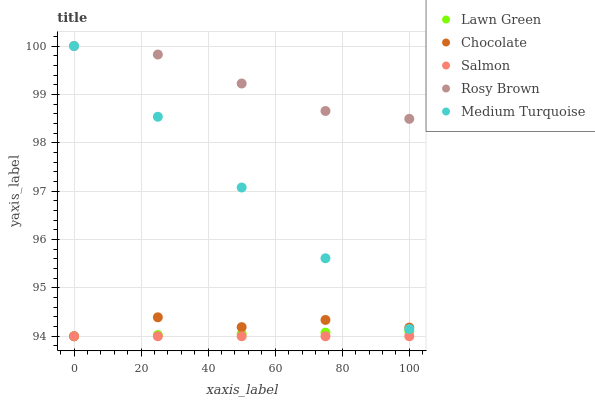Does Salmon have the minimum area under the curve?
Answer yes or no. Yes. Does Rosy Brown have the maximum area under the curve?
Answer yes or no. Yes. Does Rosy Brown have the minimum area under the curve?
Answer yes or no. No. Does Salmon have the maximum area under the curve?
Answer yes or no. No. Is Lawn Green the smoothest?
Answer yes or no. Yes. Is Chocolate the roughest?
Answer yes or no. Yes. Is Rosy Brown the smoothest?
Answer yes or no. No. Is Rosy Brown the roughest?
Answer yes or no. No. Does Lawn Green have the lowest value?
Answer yes or no. Yes. Does Rosy Brown have the lowest value?
Answer yes or no. No. Does Medium Turquoise have the highest value?
Answer yes or no. Yes. Does Salmon have the highest value?
Answer yes or no. No. Is Salmon less than Medium Turquoise?
Answer yes or no. Yes. Is Medium Turquoise greater than Salmon?
Answer yes or no. Yes. Does Chocolate intersect Salmon?
Answer yes or no. Yes. Is Chocolate less than Salmon?
Answer yes or no. No. Is Chocolate greater than Salmon?
Answer yes or no. No. Does Salmon intersect Medium Turquoise?
Answer yes or no. No. 